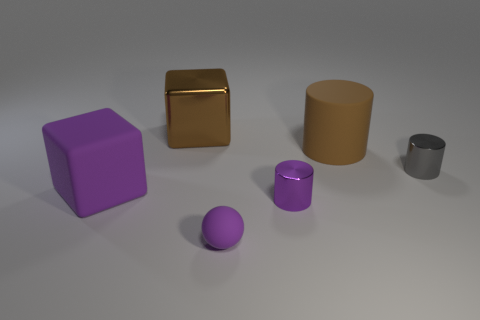What size is the shiny thing that is the same color as the rubber block?
Provide a short and direct response. Small. What material is the cylinder that is the same color as the large rubber block?
Your answer should be very brief. Metal. Is there a small cyan cylinder made of the same material as the brown block?
Your response must be concise. No. What number of brown shiny objects are the same shape as the small purple matte thing?
Provide a succinct answer. 0. What is the shape of the big object that is to the left of the block behind the large rubber object on the left side of the large brown metallic object?
Provide a short and direct response. Cube. There is a object that is to the right of the purple matte ball and in front of the gray metallic cylinder; what material is it made of?
Your answer should be compact. Metal. Does the metal thing behind the gray cylinder have the same size as the purple metallic cylinder?
Keep it short and to the point. No. Are there more purple things in front of the rubber cube than big objects that are in front of the matte ball?
Keep it short and to the point. Yes. What color is the large matte object that is right of the purple matte ball in front of the large block in front of the gray shiny object?
Provide a succinct answer. Brown. Do the tiny metal thing that is left of the tiny gray cylinder and the big rubber cylinder have the same color?
Keep it short and to the point. No. 